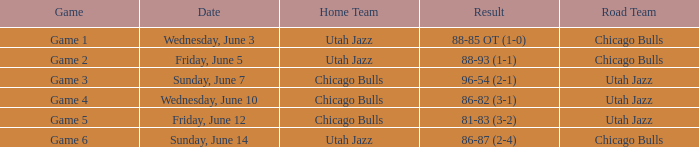Which game is associated with the score 88-85 ot (1-0)? Game 1. 